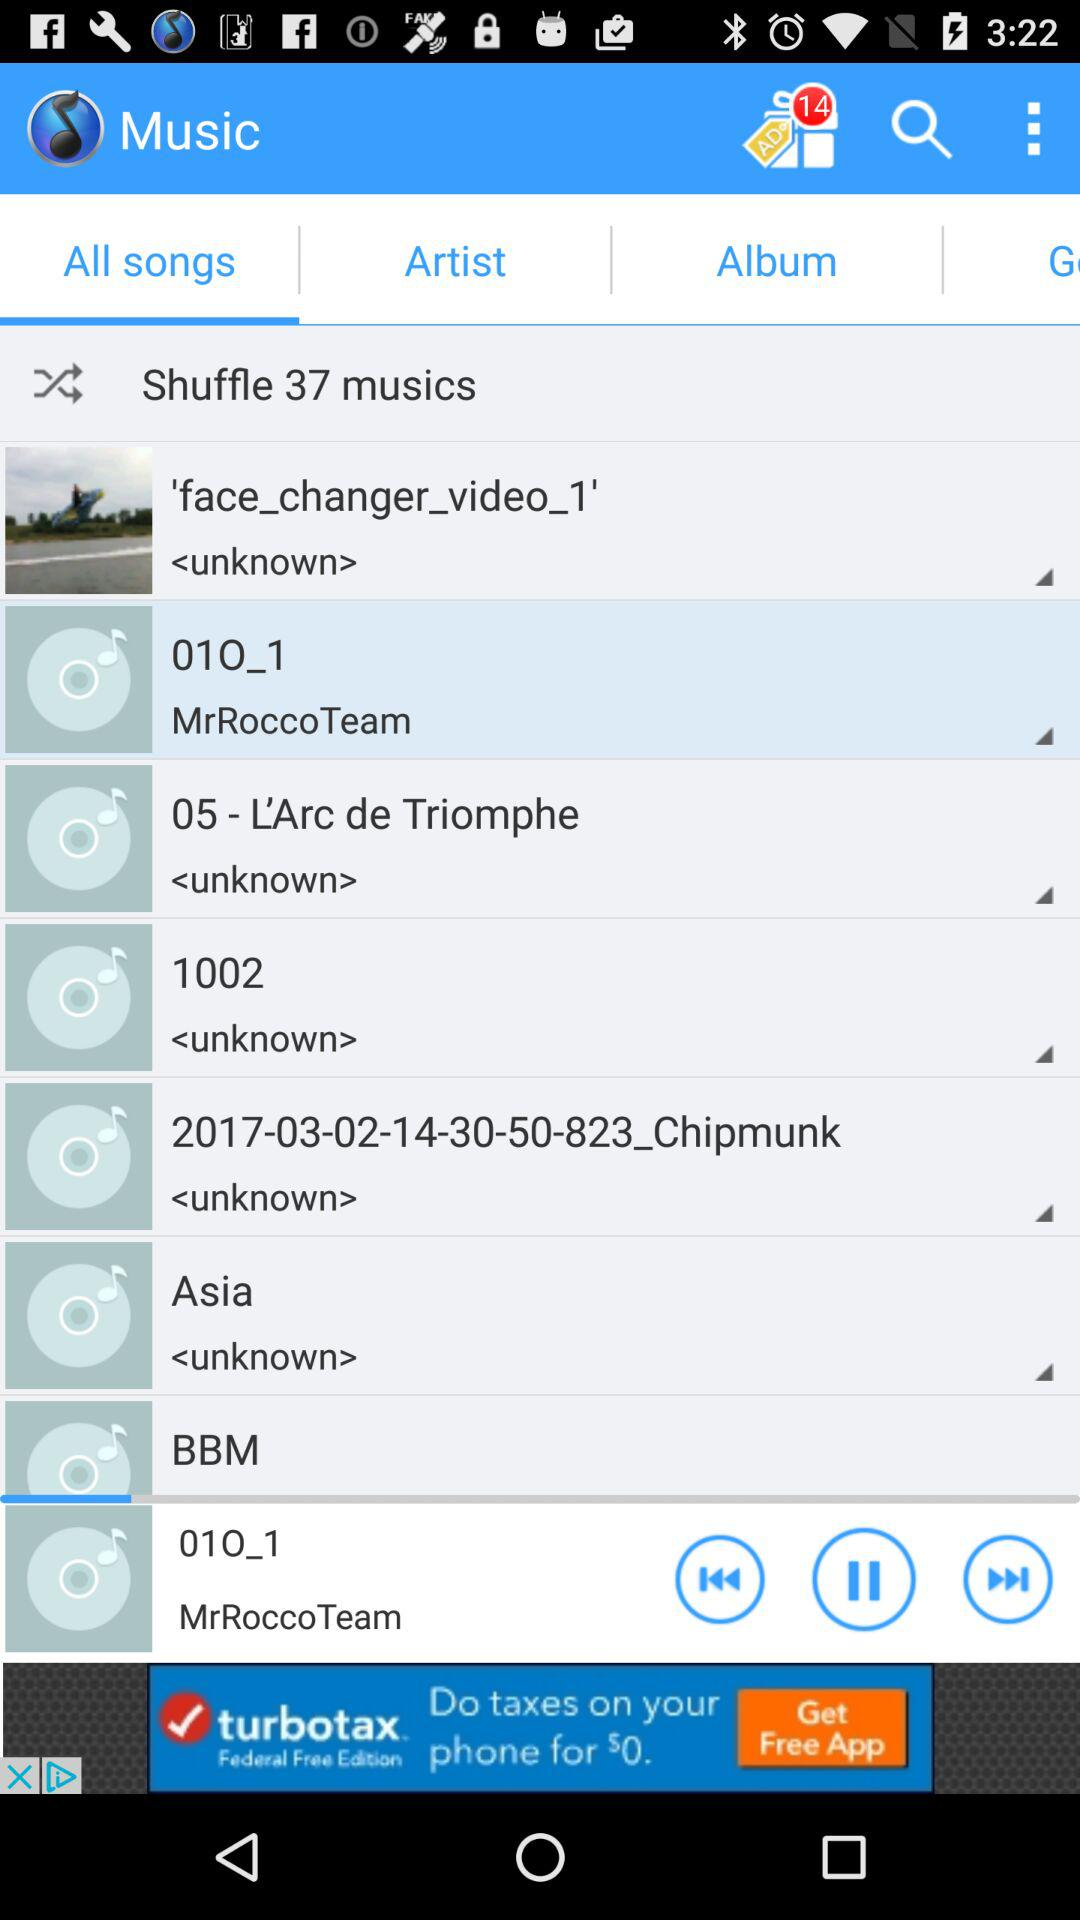How many tracks in total are there? There are 37 tracks. 